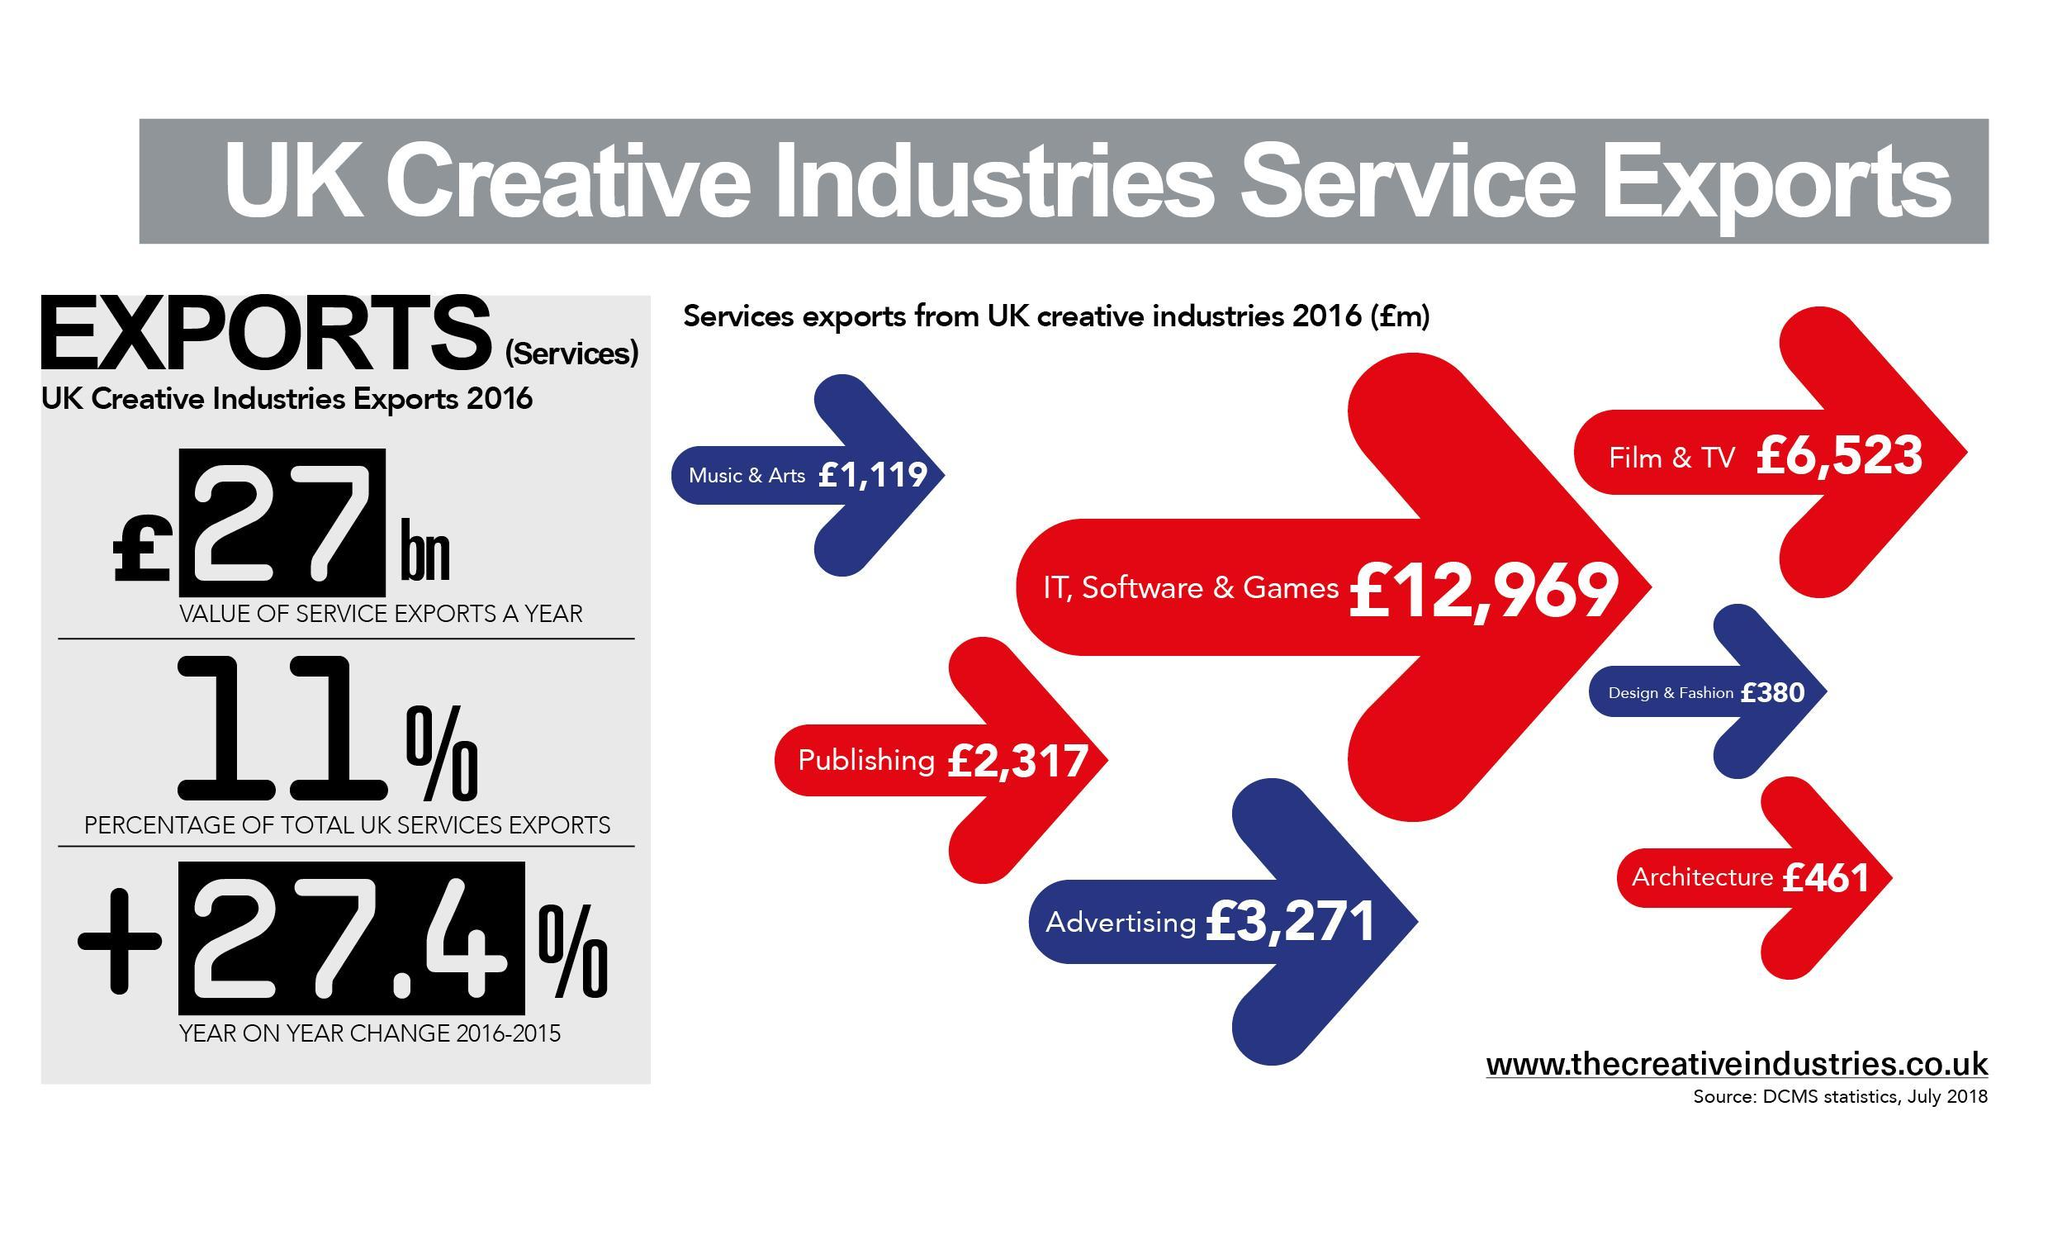Which creative industry has a second highest value of service exports IT, Software & Games , Advertising, or Film &TV ?
Answer the question with a short phrase. Film & TV What is the total value of exports from other creative industries excluding IT, Software & Games? 14,071 Pounds 